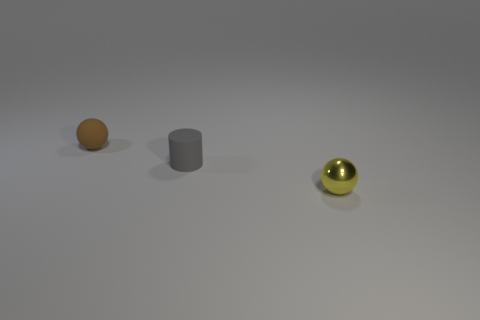The brown matte object is what shape?
Your response must be concise. Sphere. There is a thing that is to the right of the tiny gray object; what color is it?
Give a very brief answer. Yellow. Do the thing in front of the gray thing and the brown sphere have the same size?
Give a very brief answer. Yes. Does the yellow thing have the same shape as the small brown object?
Your answer should be compact. Yes. Is the number of tiny brown objects on the right side of the gray object less than the number of yellow shiny balls that are right of the small yellow shiny object?
Offer a very short reply. No. How many balls are to the left of the tiny yellow object?
Offer a terse response. 1. Do the tiny thing that is in front of the small matte cylinder and the small rubber thing on the left side of the tiny gray cylinder have the same shape?
Offer a terse response. Yes. What is the material of the object in front of the tiny rubber thing that is in front of the sphere that is to the left of the small rubber cylinder?
Your response must be concise. Metal. There is a sphere in front of the tiny brown sphere to the left of the tiny rubber cylinder; what is its material?
Offer a terse response. Metal. Is the number of matte cylinders left of the tiny brown thing less than the number of big blue metal cylinders?
Your response must be concise. No. 